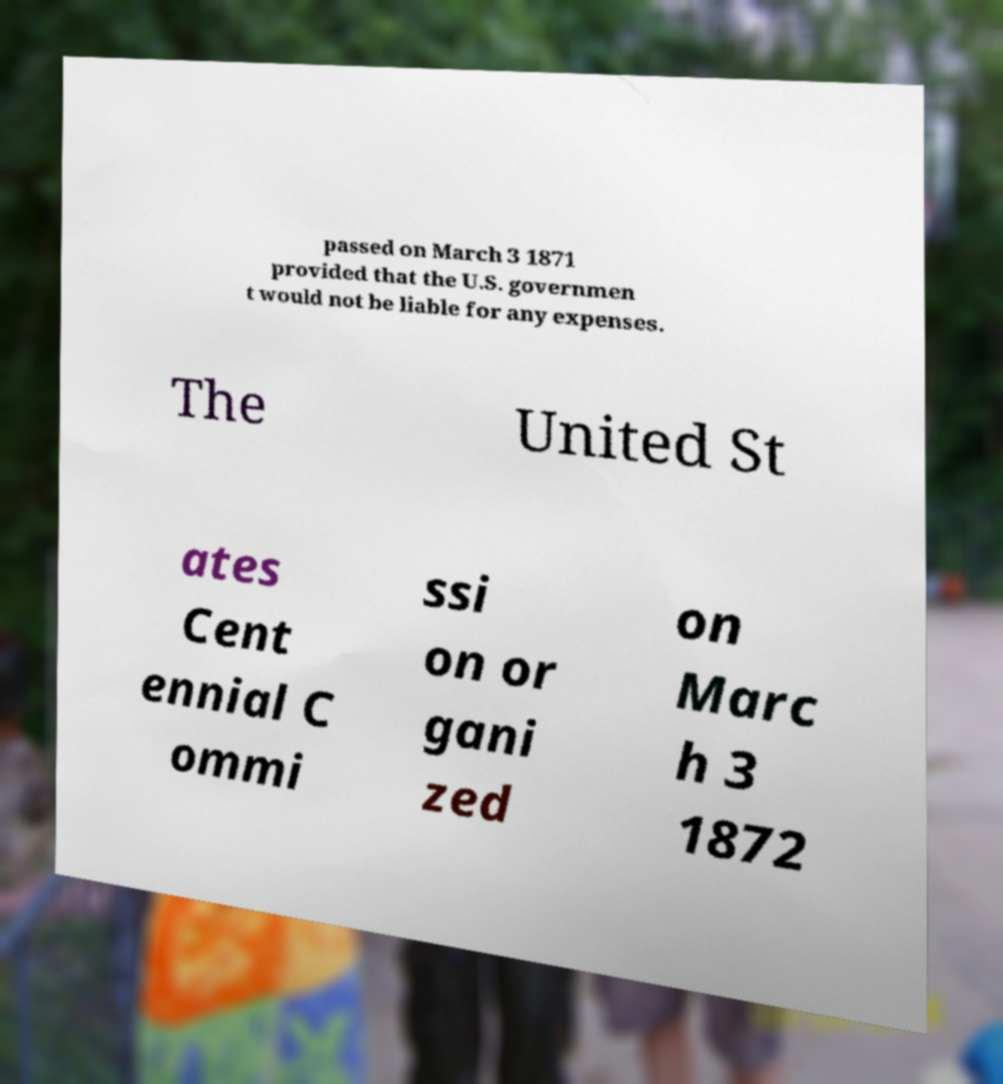What messages or text are displayed in this image? I need them in a readable, typed format. passed on March 3 1871 provided that the U.S. governmen t would not be liable for any expenses. The United St ates Cent ennial C ommi ssi on or gani zed on Marc h 3 1872 